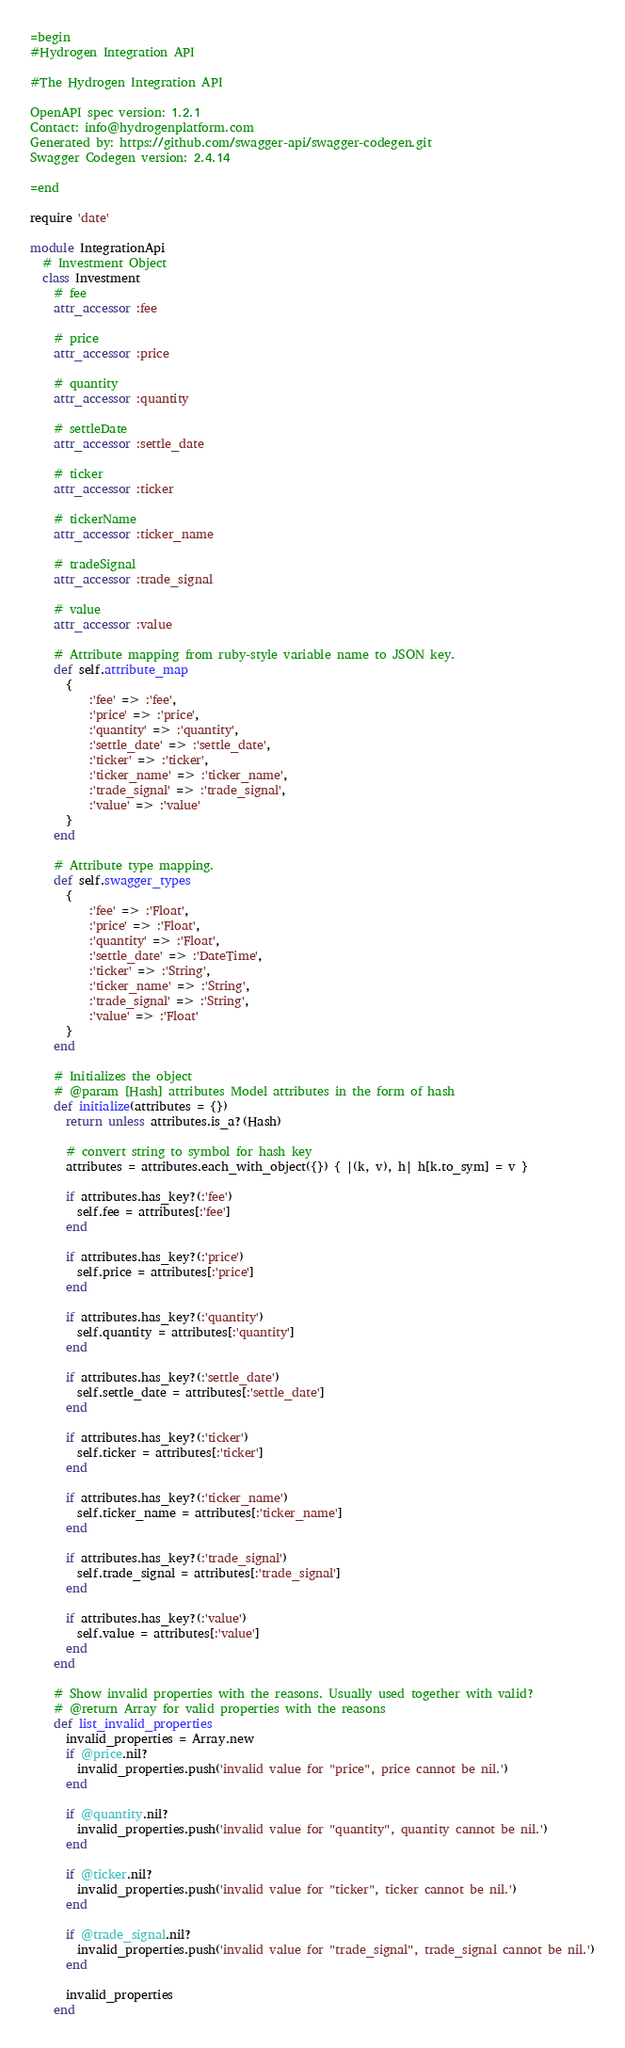Convert code to text. <code><loc_0><loc_0><loc_500><loc_500><_Ruby_>=begin
#Hydrogen Integration API

#The Hydrogen Integration API

OpenAPI spec version: 1.2.1
Contact: info@hydrogenplatform.com
Generated by: https://github.com/swagger-api/swagger-codegen.git
Swagger Codegen version: 2.4.14

=end

require 'date'

module IntegrationApi
  # Investment Object
  class Investment
    # fee
    attr_accessor :fee

    # price
    attr_accessor :price

    # quantity
    attr_accessor :quantity

    # settleDate
    attr_accessor :settle_date

    # ticker
    attr_accessor :ticker

    # tickerName
    attr_accessor :ticker_name

    # tradeSignal
    attr_accessor :trade_signal

    # value
    attr_accessor :value

    # Attribute mapping from ruby-style variable name to JSON key.
    def self.attribute_map
      {
          :'fee' => :'fee',
          :'price' => :'price',
          :'quantity' => :'quantity',
          :'settle_date' => :'settle_date',
          :'ticker' => :'ticker',
          :'ticker_name' => :'ticker_name',
          :'trade_signal' => :'trade_signal',
          :'value' => :'value'
      }
    end

    # Attribute type mapping.
    def self.swagger_types
      {
          :'fee' => :'Float',
          :'price' => :'Float',
          :'quantity' => :'Float',
          :'settle_date' => :'DateTime',
          :'ticker' => :'String',
          :'ticker_name' => :'String',
          :'trade_signal' => :'String',
          :'value' => :'Float'
      }
    end

    # Initializes the object
    # @param [Hash] attributes Model attributes in the form of hash
    def initialize(attributes = {})
      return unless attributes.is_a?(Hash)

      # convert string to symbol for hash key
      attributes = attributes.each_with_object({}) { |(k, v), h| h[k.to_sym] = v }

      if attributes.has_key?(:'fee')
        self.fee = attributes[:'fee']
      end

      if attributes.has_key?(:'price')
        self.price = attributes[:'price']
      end

      if attributes.has_key?(:'quantity')
        self.quantity = attributes[:'quantity']
      end

      if attributes.has_key?(:'settle_date')
        self.settle_date = attributes[:'settle_date']
      end

      if attributes.has_key?(:'ticker')
        self.ticker = attributes[:'ticker']
      end

      if attributes.has_key?(:'ticker_name')
        self.ticker_name = attributes[:'ticker_name']
      end

      if attributes.has_key?(:'trade_signal')
        self.trade_signal = attributes[:'trade_signal']
      end

      if attributes.has_key?(:'value')
        self.value = attributes[:'value']
      end
    end

    # Show invalid properties with the reasons. Usually used together with valid?
    # @return Array for valid properties with the reasons
    def list_invalid_properties
      invalid_properties = Array.new
      if @price.nil?
        invalid_properties.push('invalid value for "price", price cannot be nil.')
      end

      if @quantity.nil?
        invalid_properties.push('invalid value for "quantity", quantity cannot be nil.')
      end

      if @ticker.nil?
        invalid_properties.push('invalid value for "ticker", ticker cannot be nil.')
      end

      if @trade_signal.nil?
        invalid_properties.push('invalid value for "trade_signal", trade_signal cannot be nil.')
      end

      invalid_properties
    end
</code> 